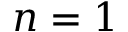Convert formula to latex. <formula><loc_0><loc_0><loc_500><loc_500>n = 1</formula> 